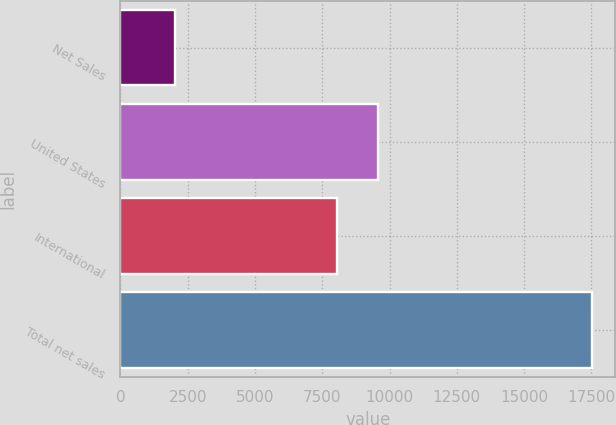Convert chart to OTSL. <chart><loc_0><loc_0><loc_500><loc_500><bar_chart><fcel>Net Sales<fcel>United States<fcel>International<fcel>Total net sales<nl><fcel>2016<fcel>9582.3<fcel>8033<fcel>17509<nl></chart> 